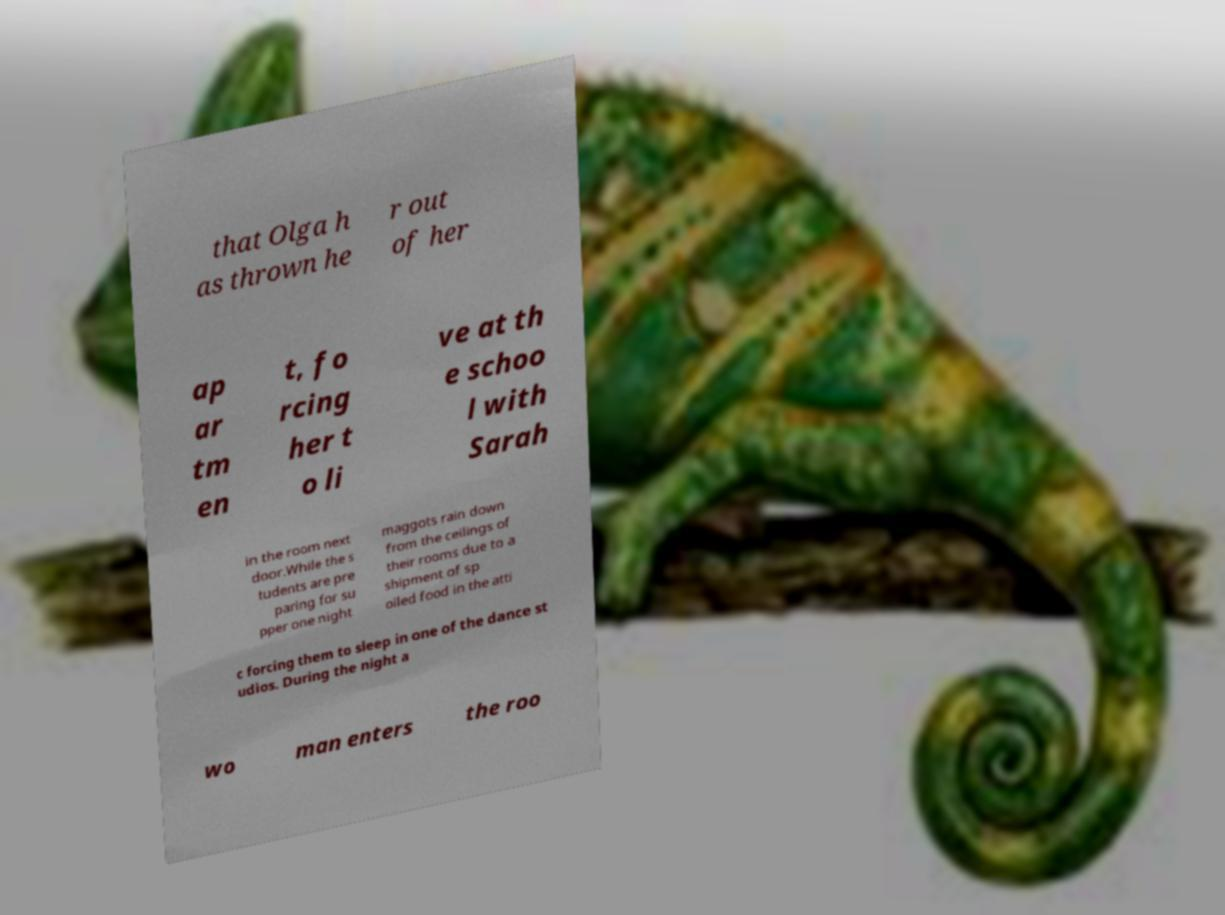Please identify and transcribe the text found in this image. that Olga h as thrown he r out of her ap ar tm en t, fo rcing her t o li ve at th e schoo l with Sarah in the room next door.While the s tudents are pre paring for su pper one night maggots rain down from the ceilings of their rooms due to a shipment of sp oiled food in the atti c forcing them to sleep in one of the dance st udios. During the night a wo man enters the roo 